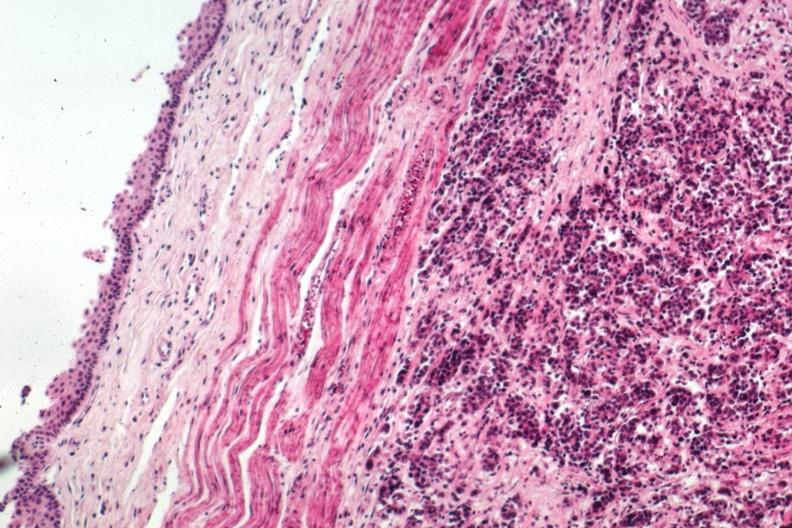s inflamed exocervix present?
Answer the question using a single word or phrase. No 